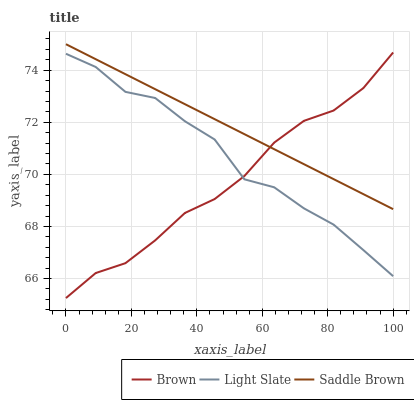Does Saddle Brown have the minimum area under the curve?
Answer yes or no. No. Does Brown have the maximum area under the curve?
Answer yes or no. No. Is Brown the smoothest?
Answer yes or no. No. Is Brown the roughest?
Answer yes or no. No. Does Saddle Brown have the lowest value?
Answer yes or no. No. Does Brown have the highest value?
Answer yes or no. No. Is Light Slate less than Saddle Brown?
Answer yes or no. Yes. Is Saddle Brown greater than Light Slate?
Answer yes or no. Yes. Does Light Slate intersect Saddle Brown?
Answer yes or no. No. 